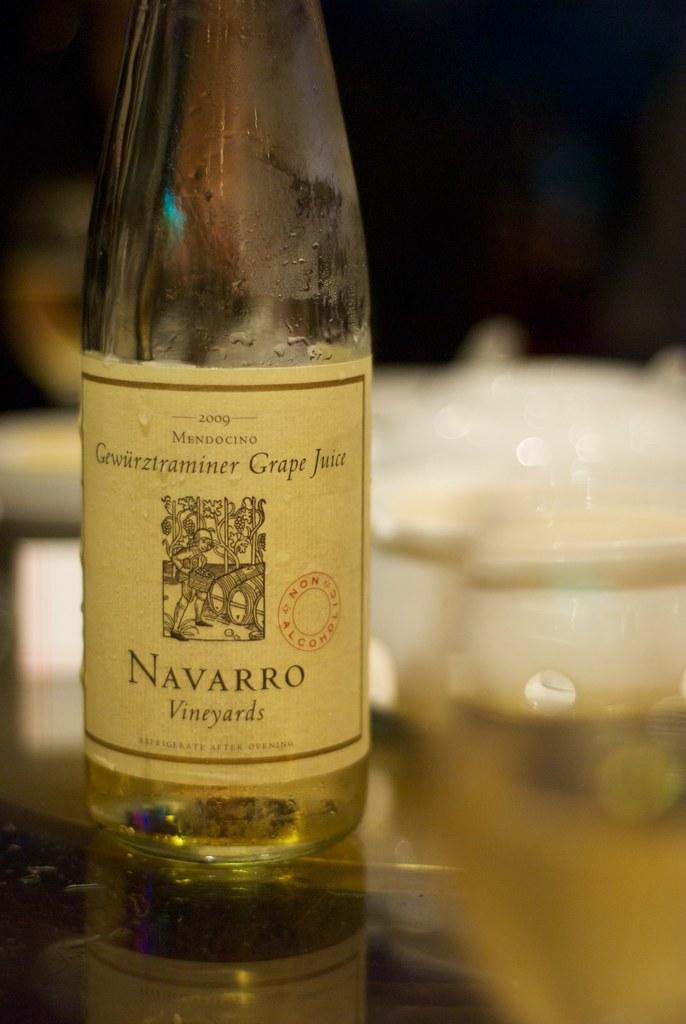Describe this image in one or two sentences. In this picture there is a bottle which is labeled as grape juice. 